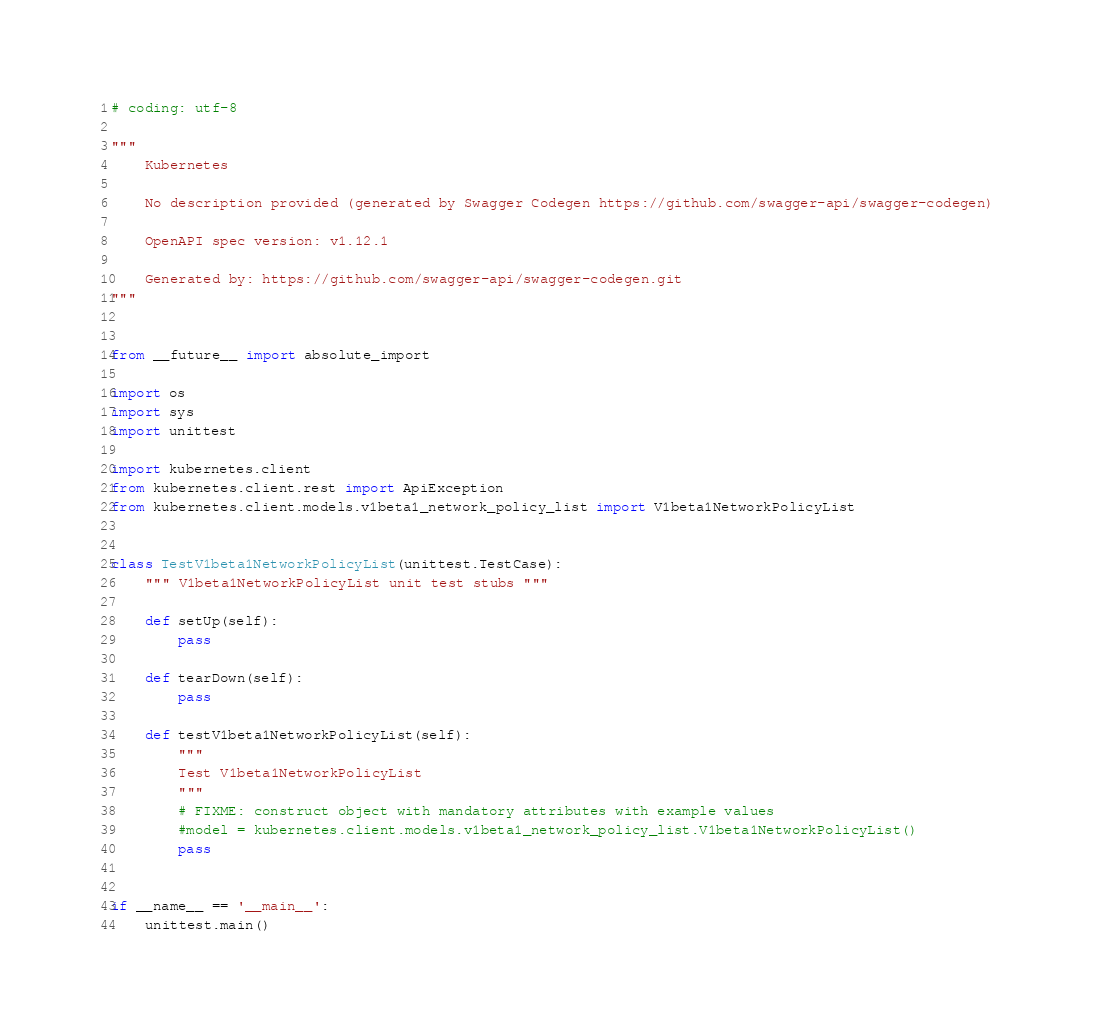<code> <loc_0><loc_0><loc_500><loc_500><_Python_># coding: utf-8

"""
    Kubernetes

    No description provided (generated by Swagger Codegen https://github.com/swagger-api/swagger-codegen)

    OpenAPI spec version: v1.12.1
    
    Generated by: https://github.com/swagger-api/swagger-codegen.git
"""


from __future__ import absolute_import

import os
import sys
import unittest

import kubernetes.client
from kubernetes.client.rest import ApiException
from kubernetes.client.models.v1beta1_network_policy_list import V1beta1NetworkPolicyList


class TestV1beta1NetworkPolicyList(unittest.TestCase):
    """ V1beta1NetworkPolicyList unit test stubs """

    def setUp(self):
        pass

    def tearDown(self):
        pass

    def testV1beta1NetworkPolicyList(self):
        """
        Test V1beta1NetworkPolicyList
        """
        # FIXME: construct object with mandatory attributes with example values
        #model = kubernetes.client.models.v1beta1_network_policy_list.V1beta1NetworkPolicyList()
        pass


if __name__ == '__main__':
    unittest.main()
</code> 